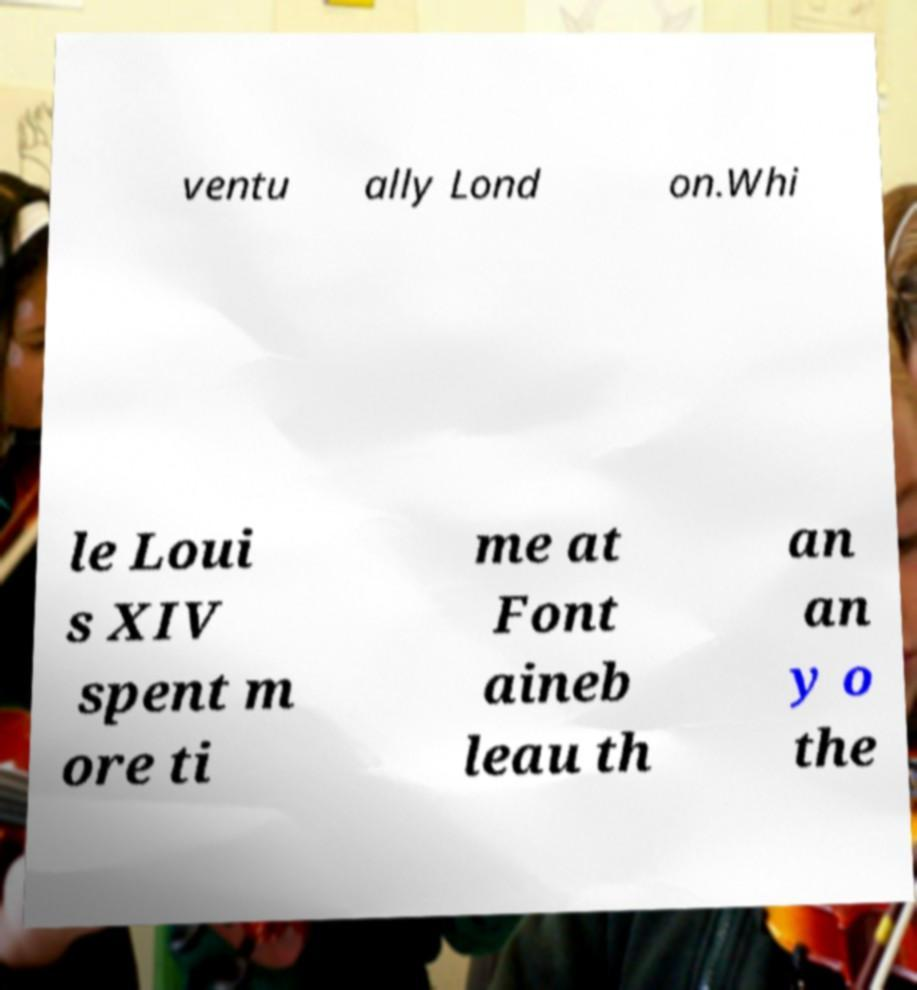What messages or text are displayed in this image? I need them in a readable, typed format. ventu ally Lond on.Whi le Loui s XIV spent m ore ti me at Font aineb leau th an an y o the 